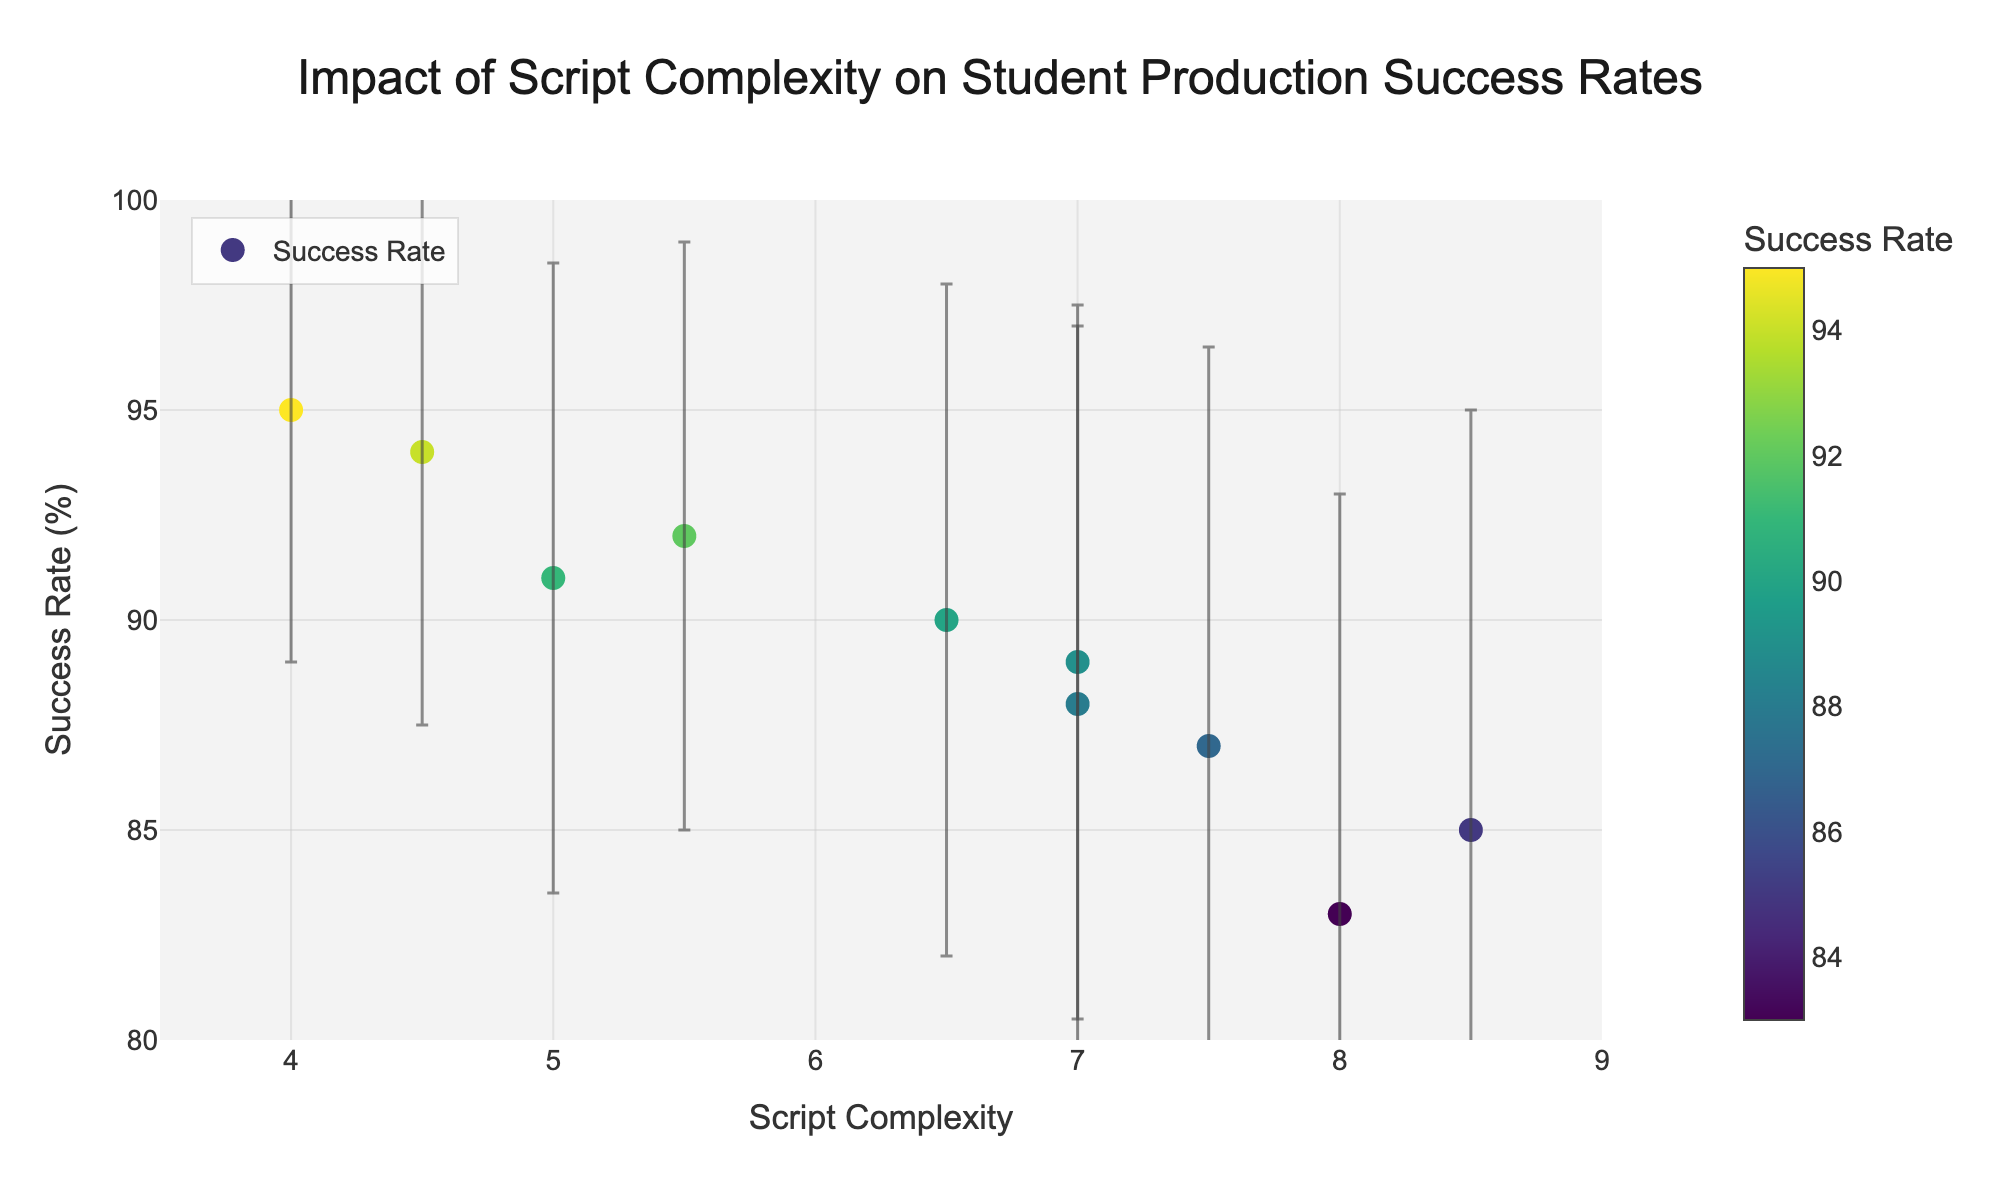What is the title of the figure? The title of the figure is located at the top center of the plot.
Answer: Impact of Script Complexity on Student Production Success Rates What is the script with the highest success rate? By examining the plot, identify the marker with the highest success rate on the y-axis.
Answer: Neil Simon's The Odd Couple Which script has the greatest error bar? Look for the data point with the longest error bar extending vertically from the point.
Answer: Shakespeare's Hamlet and Anton Chekhov's The Cherry Orchard How does the success rate of "August Wilson's Fences" compare to "Stephen Sondheim's Into the Woods"? Locate the markers for both scripts on the plot. "August Wilson's Fences" has a success rate of 92%, while "Stephen Sondheim's Into the Woods" has 89%.
Answer: "August Wilson's Fences" has a higher success rate by 3 percentage points What is the average success rate of the scripts displayed in the figure? Calculate the average by adding each success rate and dividing by the total number of scripts: (85 + 90 + 88 + 92 + 95 + 87 + 91 + 83 + 94 + 89) / 10 = 89.4
Answer: 89.4 What script complexity range do the scripts fall into? Examine the x-axis to determine the minimum and maximum script complexity values.
Answer: 4 to 8.5 Which script has the lowest success rate? Identify the data point with the lowest position on the y-axis.
Answer: Anton Chekhov's The Cherry Orchard Is there a noticeable trend between script complexity and success rate? Observe the overall pattern as script complexity increases from left to right on the x-axis and compare it with the corresponding success rates on the y-axis. There doesn't appear to be a simple linear trend.
Answer: No clear trend 